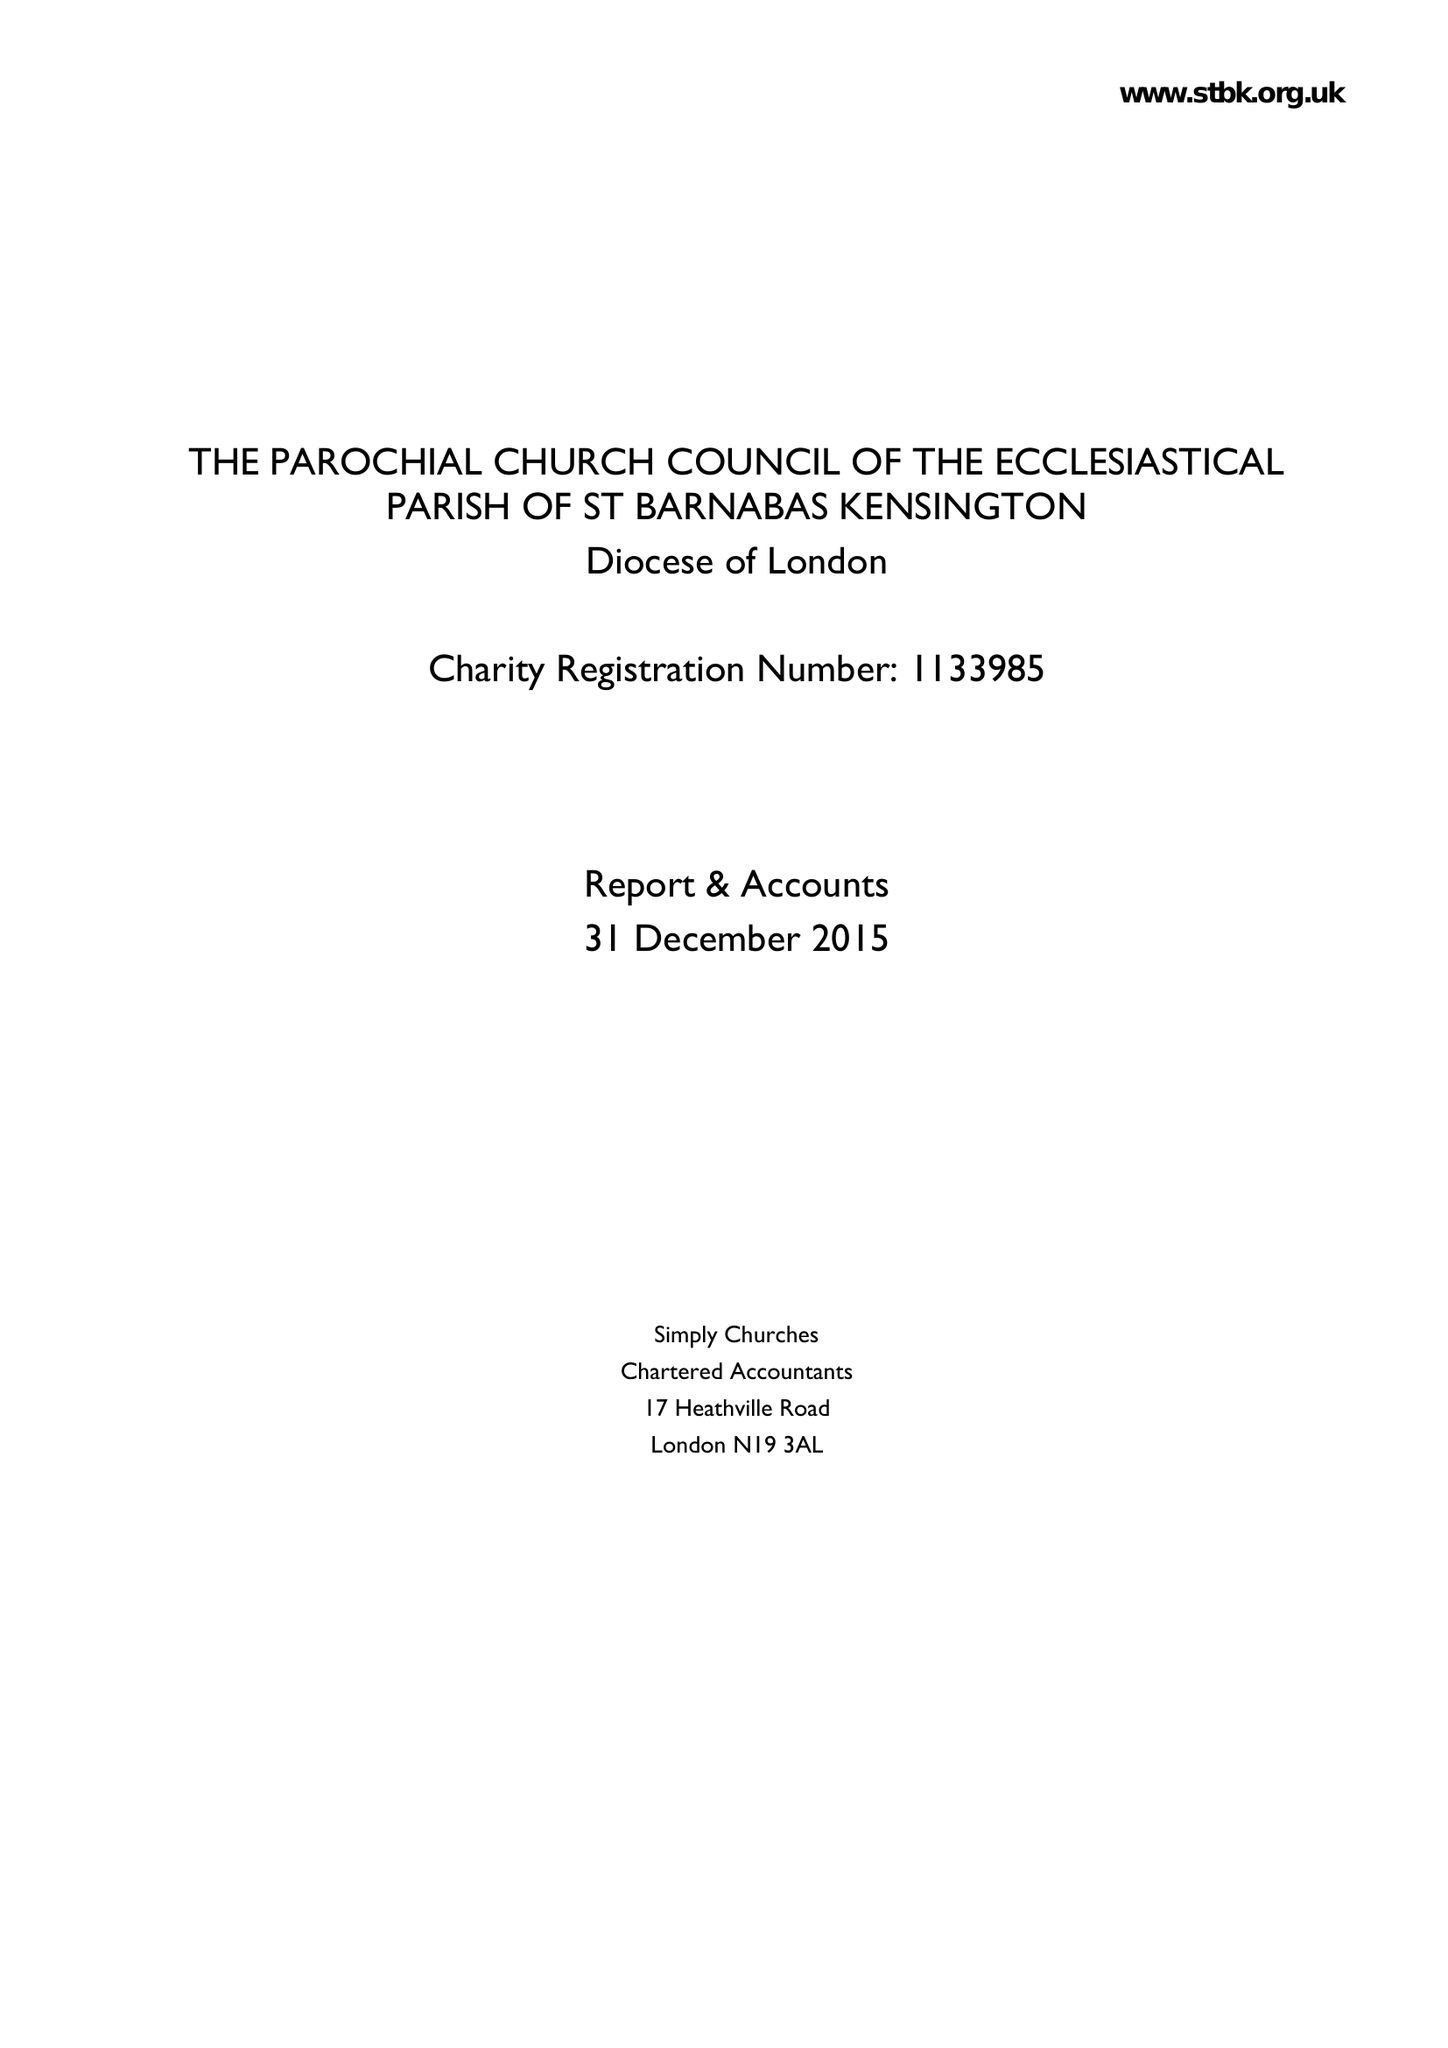What is the value for the report_date?
Answer the question using a single word or phrase. 2015-12-31 